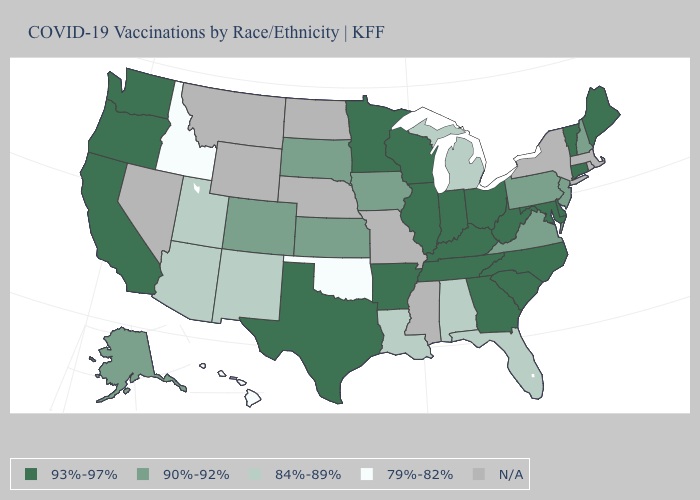Does the map have missing data?
Quick response, please. Yes. Does the map have missing data?
Concise answer only. Yes. What is the value of Hawaii?
Answer briefly. 79%-82%. What is the highest value in the USA?
Answer briefly. 93%-97%. How many symbols are there in the legend?
Short answer required. 5. Among the states that border Kansas , does Oklahoma have the lowest value?
Give a very brief answer. Yes. Among the states that border Kansas , does Colorado have the highest value?
Be succinct. Yes. Among the states that border West Virginia , which have the highest value?
Keep it brief. Kentucky, Maryland, Ohio. Which states have the highest value in the USA?
Answer briefly. Arkansas, California, Connecticut, Delaware, Georgia, Illinois, Indiana, Kentucky, Maine, Maryland, Minnesota, North Carolina, Ohio, Oregon, South Carolina, Tennessee, Texas, Vermont, Washington, West Virginia, Wisconsin. What is the lowest value in the South?
Answer briefly. 79%-82%. What is the value of Kansas?
Write a very short answer. 90%-92%. What is the highest value in the USA?
Quick response, please. 93%-97%. Among the states that border Arizona , does California have the highest value?
Write a very short answer. Yes. Does Texas have the highest value in the USA?
Be succinct. Yes. What is the value of Arkansas?
Keep it brief. 93%-97%. 